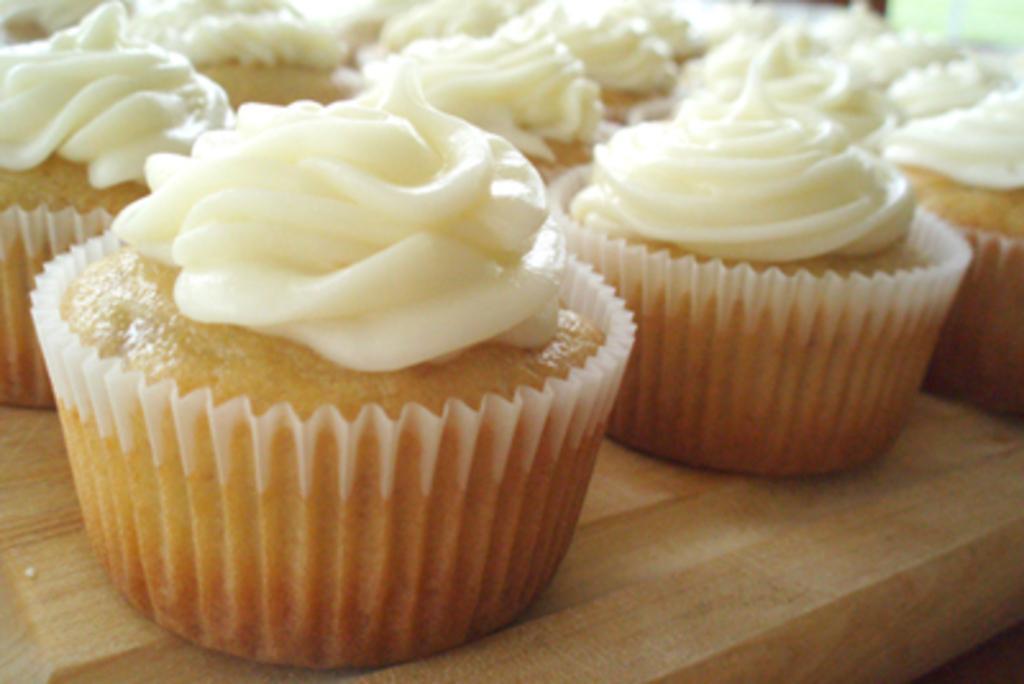Can you describe this image briefly? This is a zoomed in picture. In the foreground we can see there are many number of cupcakes placed on the top of the table. 